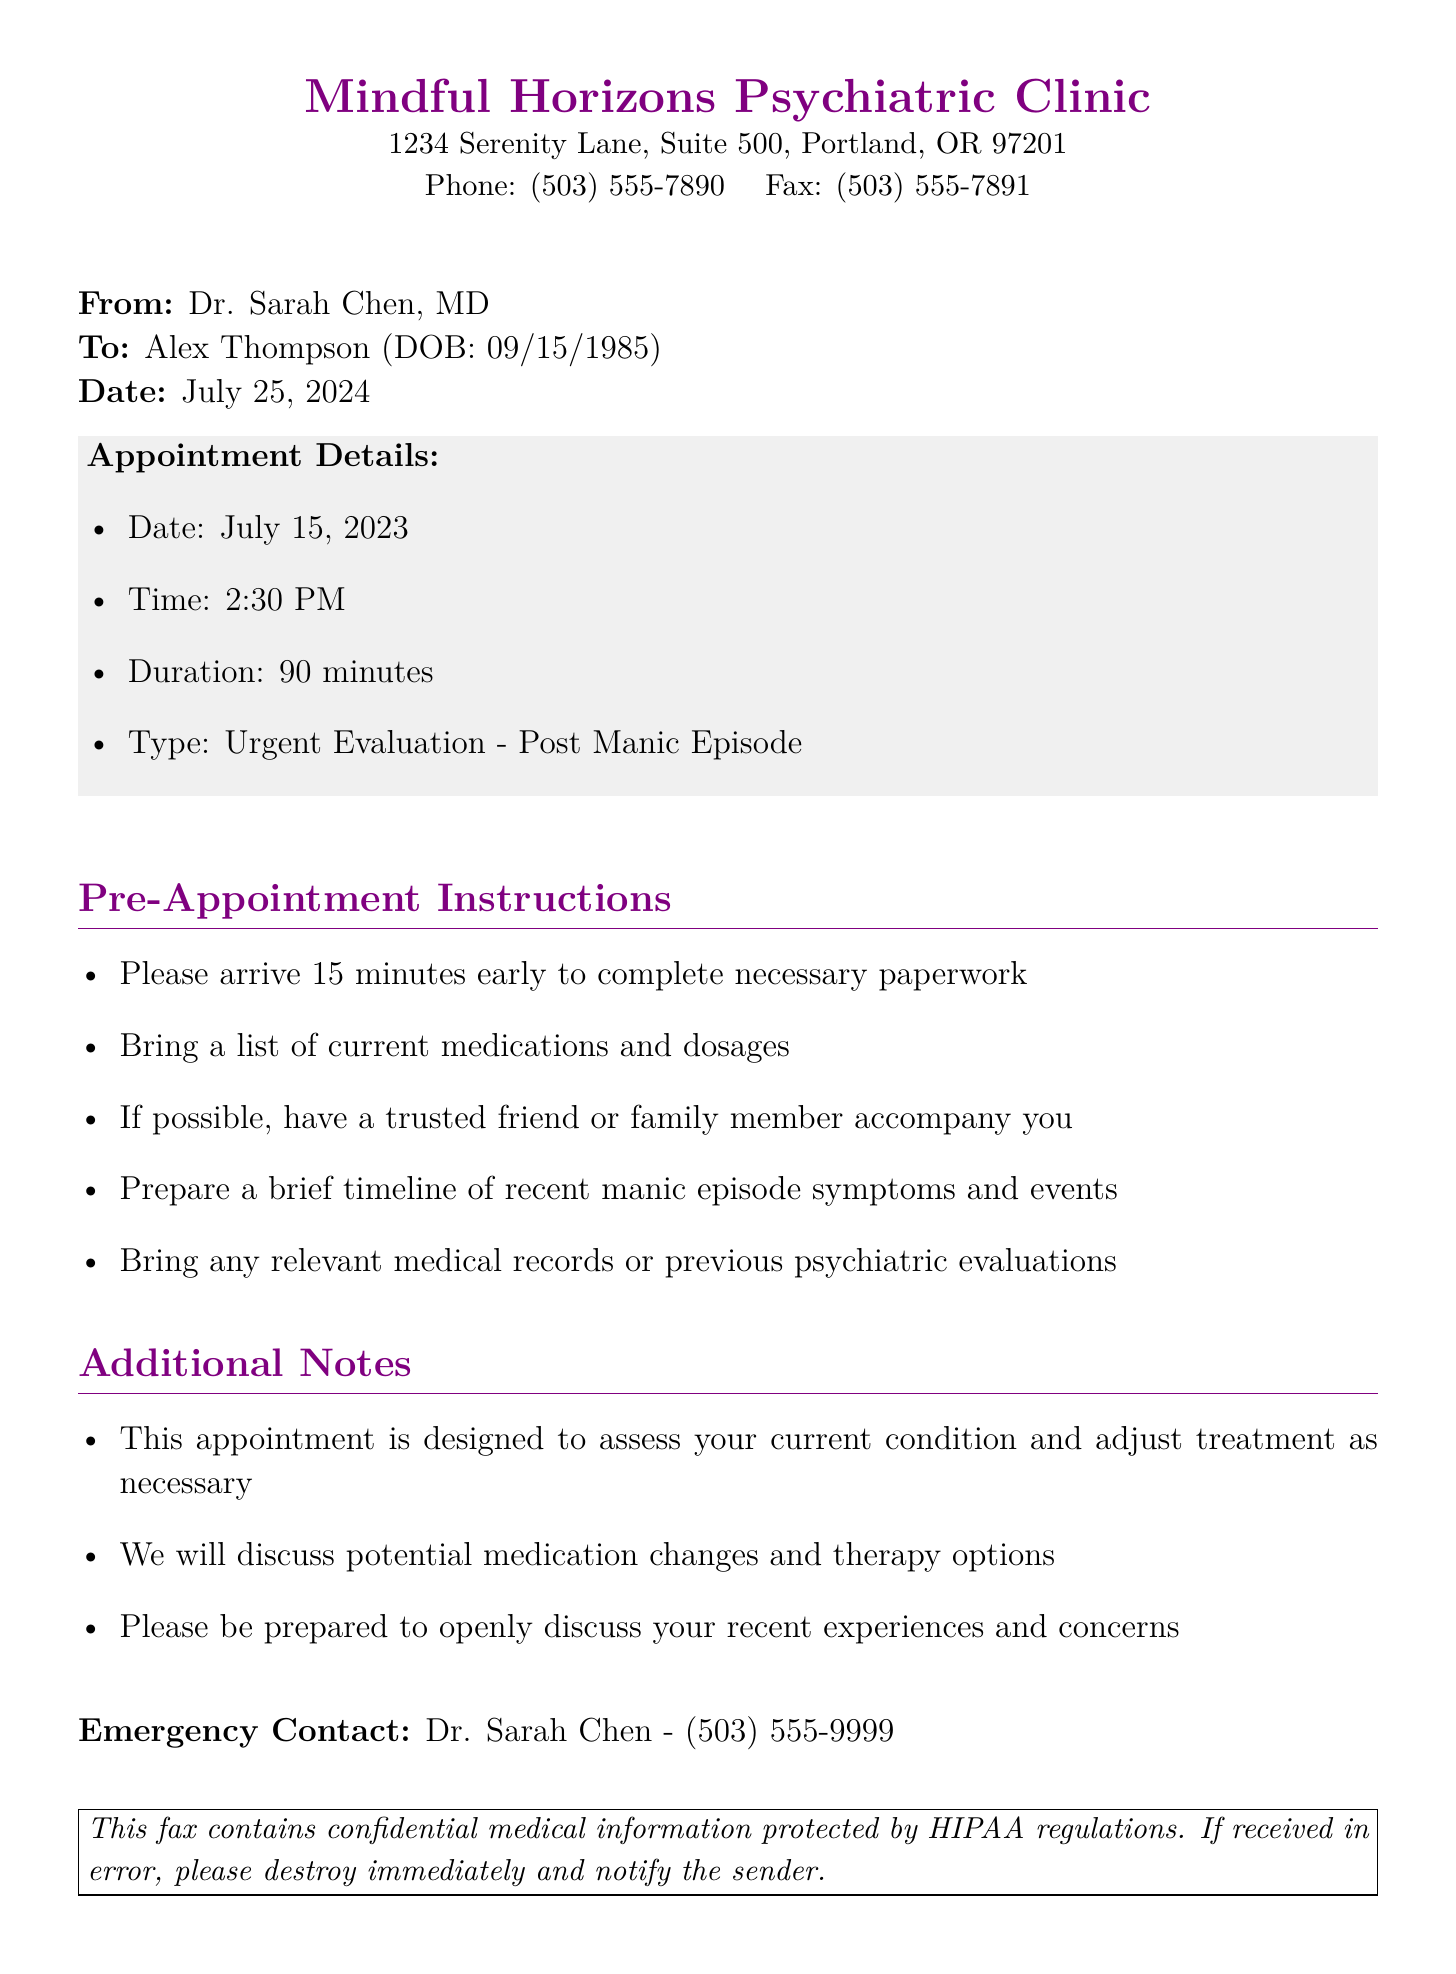What is the appointment date? The appointment date can be found in the appointment details section of the document.
Answer: July 15, 2023 Who is the psychiatrist's name? The psychiatrist's name is mentioned at the top of the document as the sender.
Answer: Dr. Sarah Chen, MD What is the duration of the appointment? The duration is specified in the appointment details section.
Answer: 90 minutes What time should the patient arrive? The pre-appointment instructions state when the patient should arrive.
Answer: 15 minutes early What type of evaluation is this appointment for? The type of evaluation is described in the appointment details list.
Answer: Urgent Evaluation - Post Manic Episode What should the patient prepare before the appointment? The pre-appointment instructions include what the patient should prepare.
Answer: Timeline of recent manic episode symptoms What is the emergency contact's phone number? The emergency contact's information is provided at the end of the document.
Answer: (503) 555-9999 What is the purpose of this appointment? The additional notes outline the purpose of the appointment.
Answer: Assess current condition and adjust treatment 